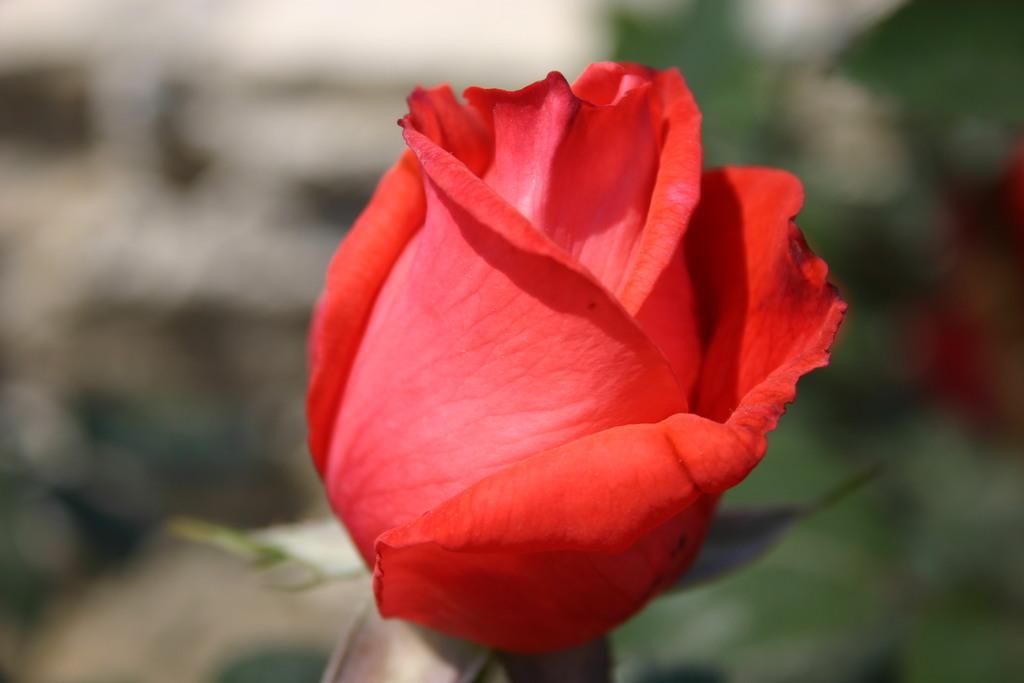In one or two sentences, can you explain what this image depicts? In this picture there is a red rose. In the back I can see the blur image. 